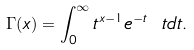Convert formula to latex. <formula><loc_0><loc_0><loc_500><loc_500>\Gamma ( x ) = \int ^ { \infty } _ { 0 } t ^ { x - 1 } e ^ { - t } \ t d t .</formula> 